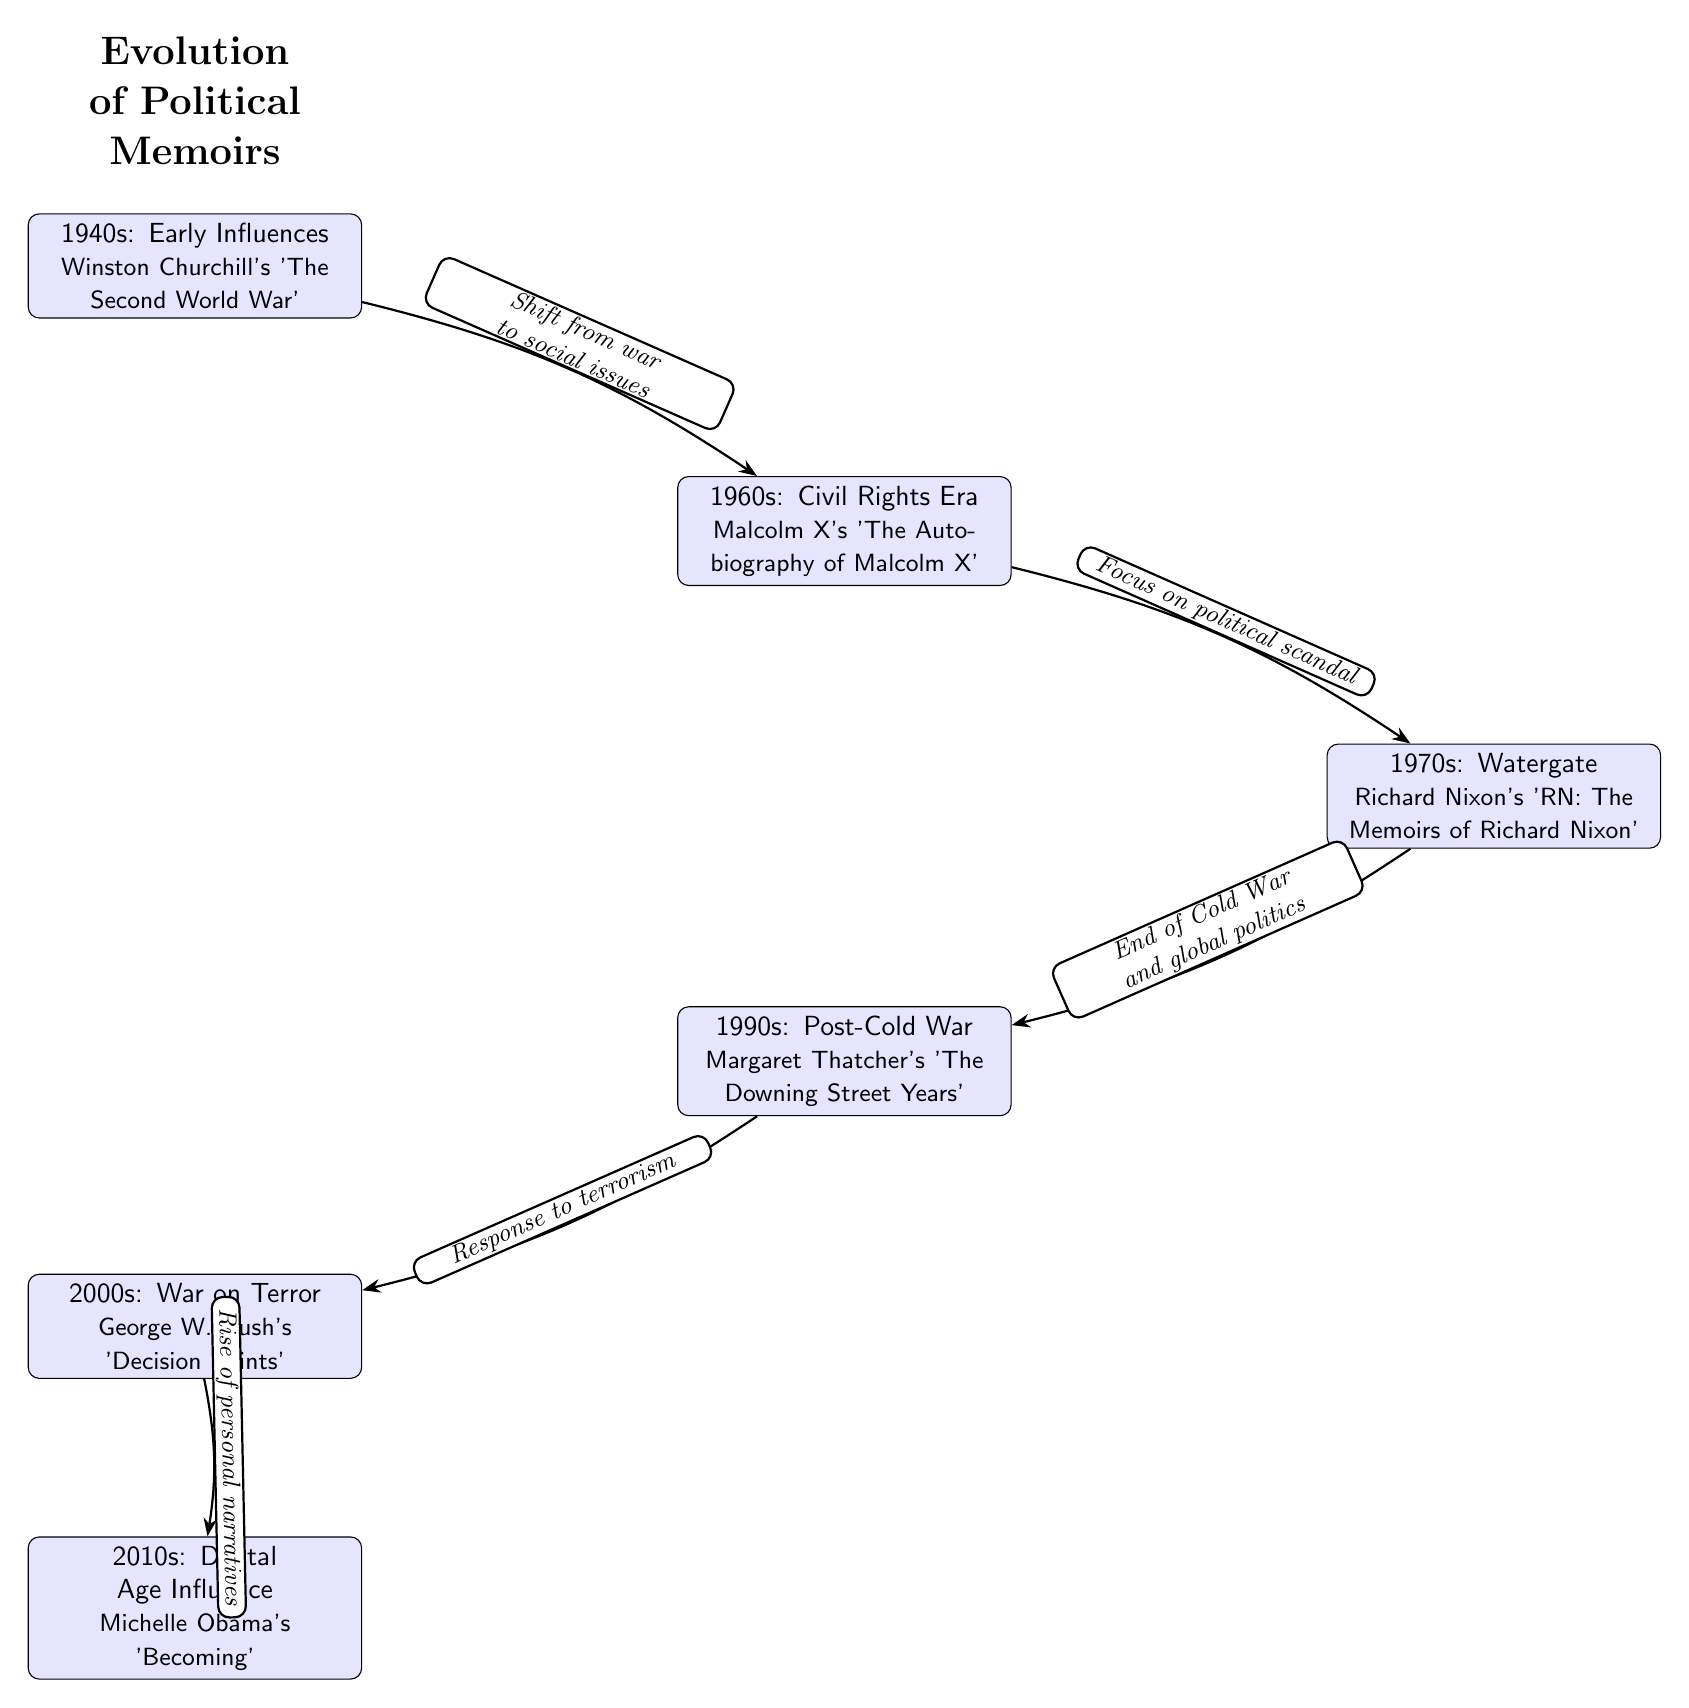What is the first political memoir mentioned in the diagram? The first node in the diagram states that the political memoir from the 1940s is Winston Churchill's "The Second World War." Therefore, the answer is derived directly from the information in that node.
Answer: Winston Churchill's 'The Second World War' How many decades are represented in the diagram? The nodes in the diagram represent political memoirs from six different decades: 1940s, 1960s, 1970s, 1990s, 2000s, and 2010s. Counting these nodes gives a total of six.
Answer: 6 What memoir corresponds to the 1970s? The node labeled for the 1970s indicates Richard Nixon's memoir titled "RN: The Memoirs of Richard Nixon." This specific memoir is directly referenced in that node.
Answer: Richard Nixon's 'RN: The Memoirs of Richard Nixon' What is the relationship between the 1960s and 1970s nodes? The edge connecting the 1960s node to the 1970s node is labeled "Focus on political scandal," indicating the thematic shift in political memoirs during that period. This relationship is reflected in the diagram’s edge labeling.
Answer: Focus on political scandal Which memoir is associated with the Digital Age influence? The 2010s node in the diagram references Michelle Obama's "Becoming," which corresponds to the Digital Age influence. This information comes directly from the text in that node.
Answer: Michelle Obama's 'Becoming' What shift occurs from the 2000s to the 2010s? The edge connecting the 2000s node to the 2010s node is labeled "Rise of personal narratives," which indicates a significant thematic development from political memoirs focused on events (like the War on Terror) to more personal storytelling in the subsequent decade.
Answer: Rise of personal narratives Which decade features a memoir related to the Civil Rights Era? The node for the 1960s features Malcolm X's "The Autobiography of Malcolm X," which is directly tied to the Civil Rights Era as stated in the node description. Therefore, the answer corresponds to that specific node.
Answer: 1960s How does the 1990s node relate to the end of the Cold War? The edge label connecting the 1970s node to the 1990s node reads "End of Cold War and global politics," indicating that the political memoirs of the 1990s respond to the changes that occurred at the close of the Cold War, reflecting shifts in public opinion and global politics.
Answer: End of Cold War and global politics 